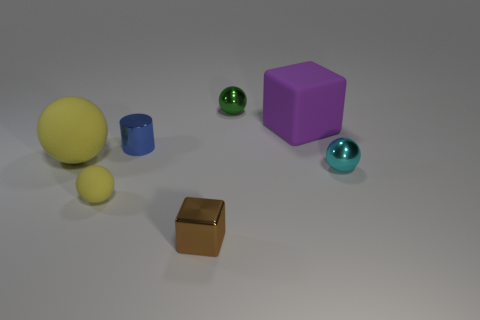The blue cylinder is what size?
Keep it short and to the point. Small. Do the yellow sphere to the left of the small yellow matte object and the cylinder have the same material?
Ensure brevity in your answer.  No. What number of large purple balls are there?
Provide a short and direct response. 0. How many things are large cyan metal cylinders or big yellow rubber objects?
Make the answer very short. 1. How many small objects are to the left of the yellow matte sphere behind the tiny ball that is on the right side of the purple thing?
Make the answer very short. 0. Is there anything else of the same color as the large rubber ball?
Keep it short and to the point. Yes. There is a big rubber thing that is to the right of the small brown cube; is it the same color as the tiny metallic ball that is in front of the purple cube?
Offer a terse response. No. Is the number of purple rubber cubes that are right of the large purple block greater than the number of tiny cubes behind the tiny brown cube?
Make the answer very short. No. What is the tiny blue cylinder made of?
Make the answer very short. Metal. What shape is the matte thing that is in front of the small shiny sphere in front of the block to the right of the tiny brown metal cube?
Provide a succinct answer. Sphere. 